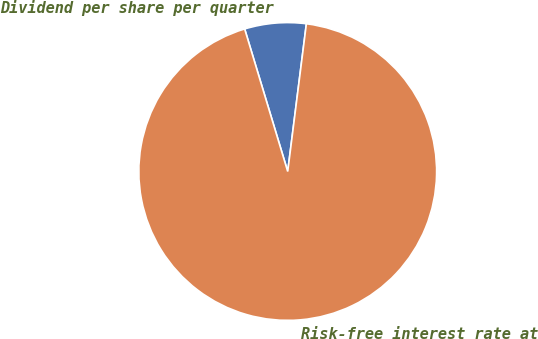<chart> <loc_0><loc_0><loc_500><loc_500><pie_chart><fcel>Dividend per share per quarter<fcel>Risk-free interest rate at<nl><fcel>6.67%<fcel>93.33%<nl></chart> 